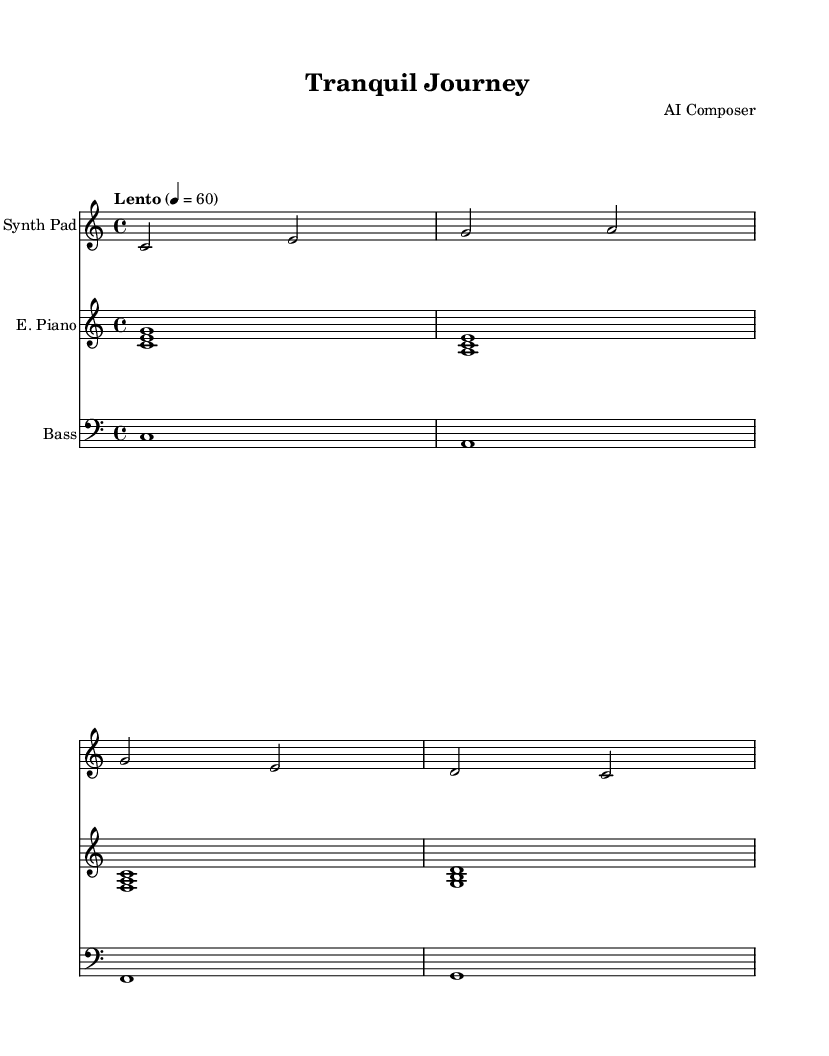What is the key signature of this music? The key signature is indicated at the beginning of the staff, which is C major. This key has no sharps or flats.
Answer: C major What is the time signature of this piece? The time signature is found at the beginning of the sheet music, which is 4/4. This means there are four beats in each measure, and the quarter note gets one beat.
Answer: 4/4 What is the tempo marking for this music? The tempo marking is written above the staff. It states "Lento," which indicates a slow tempo, generally meaning a speed of 60 beats per minute in this context.
Answer: Lento How many measures are there in the synthesizer part? By counting the measures in the synthesizer section, there are four measures total. Each vertical line indicates the end of a measure.
Answer: 4 What is the highest note played by the synthesizer? The highest note is found by examining the notes played in the synthesizer part. The highest note in this section is "a" in the second measure.
Answer: a What instrument plays the bass line? The instrument indicated in the part labeled "Bass" is responsible for the lowest harmonic support in the music, which is assigned to a single staff labeled "Bass" typically played by a bass instrument.
Answer: Bass Which chord is played in the electric piano during the first measure? The electric piano part shows three notes played simultaneously, forming a chord. The notes shown are C, E, and G, which together make a C major chord.
Answer: C major 